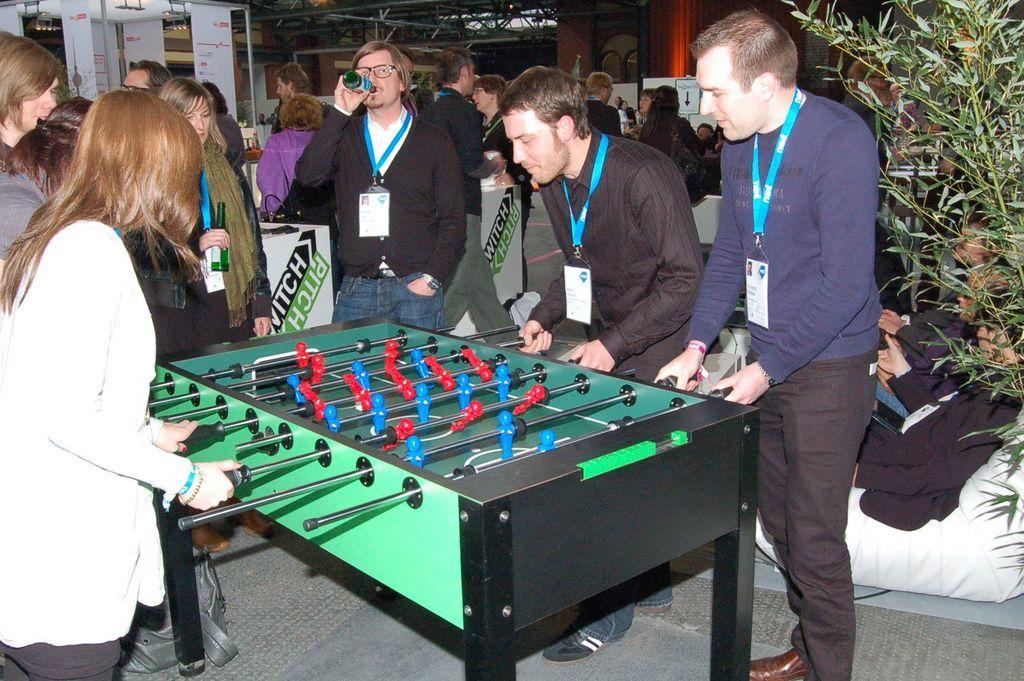Could you give a brief overview of what you see in this image? In this image there is a game table. People are playing the game. There are other people standing in the background. There is a tree on the right side. 